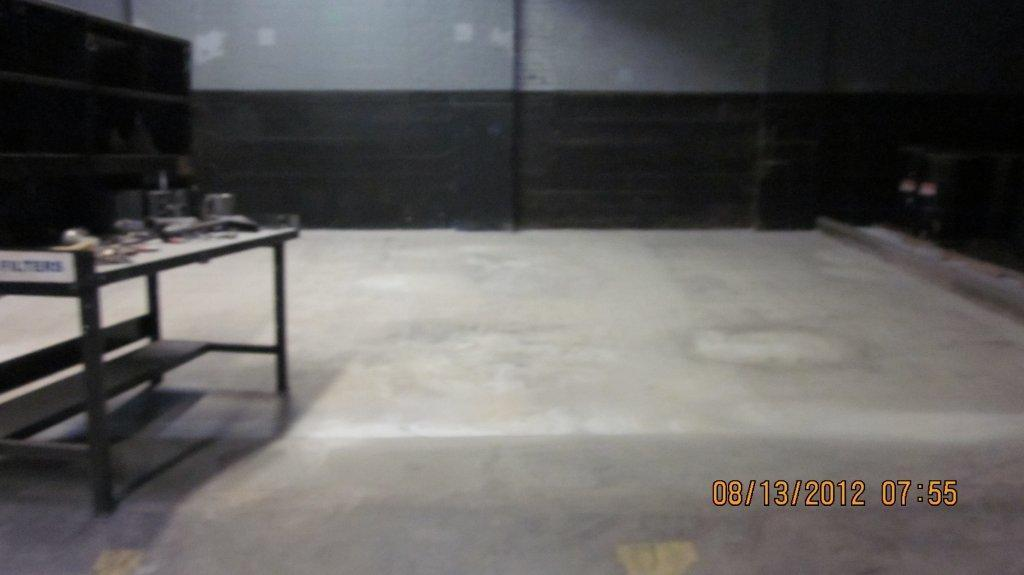What object is located on the left side of the image? There is a table on the left side of the image. What is happening to the table in the image? Something is pressing on the table. How is the sleet being distributed on the table in the image? There is no sleet present in the image, so it cannot be distributed on the table. 